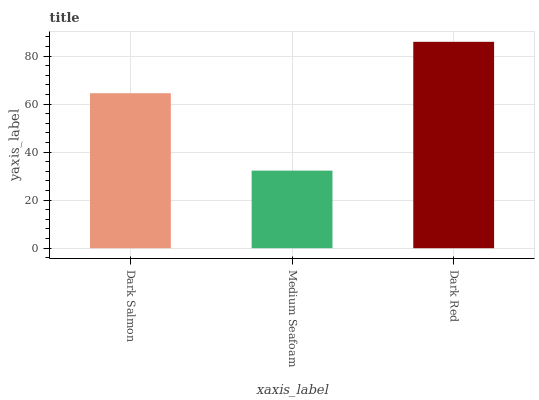Is Medium Seafoam the minimum?
Answer yes or no. Yes. Is Dark Red the maximum?
Answer yes or no. Yes. Is Dark Red the minimum?
Answer yes or no. No. Is Medium Seafoam the maximum?
Answer yes or no. No. Is Dark Red greater than Medium Seafoam?
Answer yes or no. Yes. Is Medium Seafoam less than Dark Red?
Answer yes or no. Yes. Is Medium Seafoam greater than Dark Red?
Answer yes or no. No. Is Dark Red less than Medium Seafoam?
Answer yes or no. No. Is Dark Salmon the high median?
Answer yes or no. Yes. Is Dark Salmon the low median?
Answer yes or no. Yes. Is Medium Seafoam the high median?
Answer yes or no. No. Is Medium Seafoam the low median?
Answer yes or no. No. 